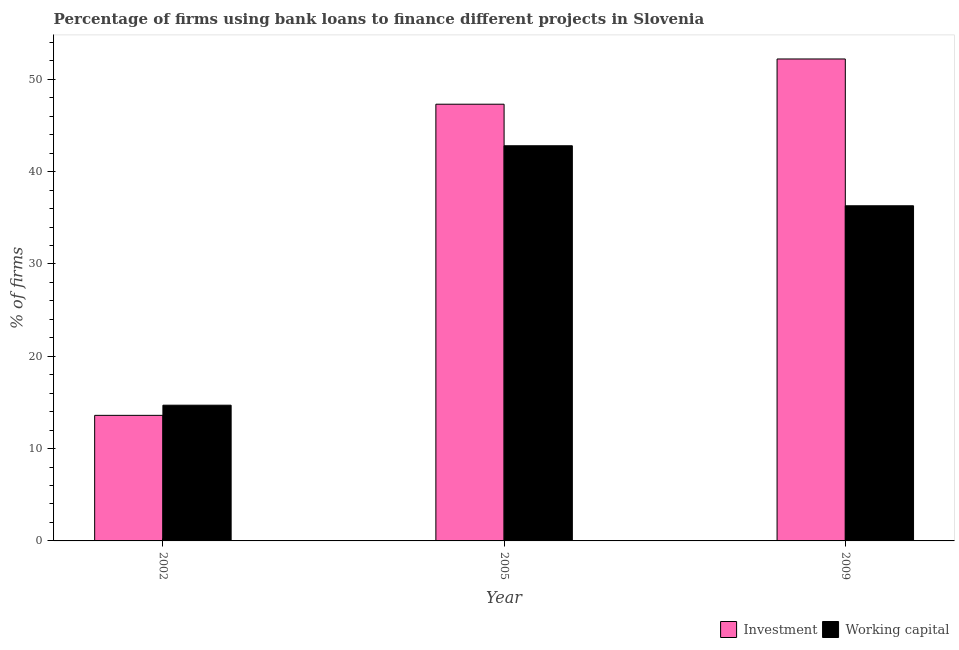How many different coloured bars are there?
Offer a very short reply. 2. How many bars are there on the 3rd tick from the right?
Make the answer very short. 2. What is the percentage of firms using banks to finance working capital in 2005?
Make the answer very short. 42.8. Across all years, what is the maximum percentage of firms using banks to finance working capital?
Offer a terse response. 42.8. Across all years, what is the minimum percentage of firms using banks to finance investment?
Your answer should be very brief. 13.6. In which year was the percentage of firms using banks to finance working capital minimum?
Keep it short and to the point. 2002. What is the total percentage of firms using banks to finance investment in the graph?
Your response must be concise. 113.1. What is the difference between the percentage of firms using banks to finance investment in 2002 and that in 2009?
Provide a short and direct response. -38.6. What is the average percentage of firms using banks to finance working capital per year?
Keep it short and to the point. 31.27. In the year 2009, what is the difference between the percentage of firms using banks to finance investment and percentage of firms using banks to finance working capital?
Ensure brevity in your answer.  0. What is the ratio of the percentage of firms using banks to finance working capital in 2002 to that in 2005?
Provide a succinct answer. 0.34. Is the percentage of firms using banks to finance investment in 2002 less than that in 2009?
Offer a terse response. Yes. Is the difference between the percentage of firms using banks to finance working capital in 2002 and 2005 greater than the difference between the percentage of firms using banks to finance investment in 2002 and 2005?
Keep it short and to the point. No. What is the difference between the highest and the second highest percentage of firms using banks to finance investment?
Your answer should be very brief. 4.9. What is the difference between the highest and the lowest percentage of firms using banks to finance working capital?
Provide a short and direct response. 28.1. What does the 1st bar from the left in 2009 represents?
Give a very brief answer. Investment. What does the 2nd bar from the right in 2009 represents?
Your answer should be compact. Investment. How many years are there in the graph?
Provide a short and direct response. 3. Are the values on the major ticks of Y-axis written in scientific E-notation?
Give a very brief answer. No. Does the graph contain any zero values?
Keep it short and to the point. No. Does the graph contain grids?
Provide a succinct answer. No. Where does the legend appear in the graph?
Provide a succinct answer. Bottom right. How many legend labels are there?
Provide a succinct answer. 2. What is the title of the graph?
Give a very brief answer. Percentage of firms using bank loans to finance different projects in Slovenia. What is the label or title of the Y-axis?
Your response must be concise. % of firms. What is the % of firms of Investment in 2002?
Make the answer very short. 13.6. What is the % of firms of Investment in 2005?
Give a very brief answer. 47.3. What is the % of firms of Working capital in 2005?
Provide a succinct answer. 42.8. What is the % of firms of Investment in 2009?
Keep it short and to the point. 52.2. What is the % of firms of Working capital in 2009?
Provide a short and direct response. 36.3. Across all years, what is the maximum % of firms in Investment?
Provide a short and direct response. 52.2. Across all years, what is the maximum % of firms in Working capital?
Offer a very short reply. 42.8. Across all years, what is the minimum % of firms of Investment?
Give a very brief answer. 13.6. Across all years, what is the minimum % of firms of Working capital?
Provide a succinct answer. 14.7. What is the total % of firms in Investment in the graph?
Provide a short and direct response. 113.1. What is the total % of firms of Working capital in the graph?
Offer a very short reply. 93.8. What is the difference between the % of firms in Investment in 2002 and that in 2005?
Give a very brief answer. -33.7. What is the difference between the % of firms of Working capital in 2002 and that in 2005?
Your answer should be compact. -28.1. What is the difference between the % of firms in Investment in 2002 and that in 2009?
Your answer should be very brief. -38.6. What is the difference between the % of firms of Working capital in 2002 and that in 2009?
Your answer should be compact. -21.6. What is the difference between the % of firms of Working capital in 2005 and that in 2009?
Provide a short and direct response. 6.5. What is the difference between the % of firms in Investment in 2002 and the % of firms in Working capital in 2005?
Offer a terse response. -29.2. What is the difference between the % of firms of Investment in 2002 and the % of firms of Working capital in 2009?
Provide a succinct answer. -22.7. What is the difference between the % of firms of Investment in 2005 and the % of firms of Working capital in 2009?
Your answer should be compact. 11. What is the average % of firms of Investment per year?
Your response must be concise. 37.7. What is the average % of firms in Working capital per year?
Give a very brief answer. 31.27. In the year 2009, what is the difference between the % of firms of Investment and % of firms of Working capital?
Provide a succinct answer. 15.9. What is the ratio of the % of firms in Investment in 2002 to that in 2005?
Offer a terse response. 0.29. What is the ratio of the % of firms of Working capital in 2002 to that in 2005?
Provide a short and direct response. 0.34. What is the ratio of the % of firms of Investment in 2002 to that in 2009?
Provide a succinct answer. 0.26. What is the ratio of the % of firms of Working capital in 2002 to that in 2009?
Ensure brevity in your answer.  0.41. What is the ratio of the % of firms in Investment in 2005 to that in 2009?
Give a very brief answer. 0.91. What is the ratio of the % of firms in Working capital in 2005 to that in 2009?
Your answer should be very brief. 1.18. What is the difference between the highest and the second highest % of firms in Investment?
Your response must be concise. 4.9. What is the difference between the highest and the lowest % of firms of Investment?
Offer a very short reply. 38.6. What is the difference between the highest and the lowest % of firms of Working capital?
Ensure brevity in your answer.  28.1. 